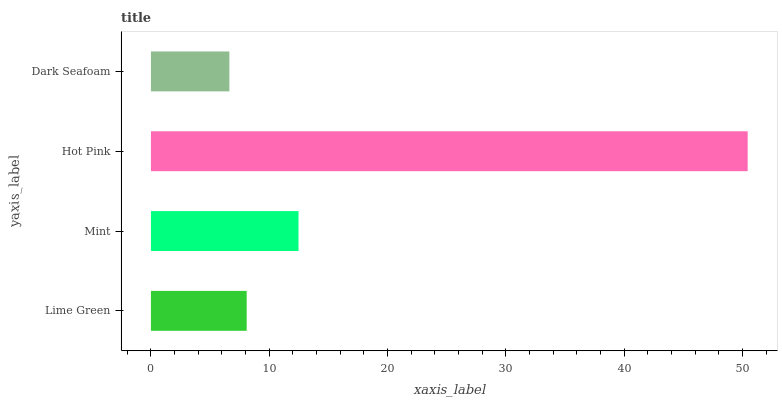Is Dark Seafoam the minimum?
Answer yes or no. Yes. Is Hot Pink the maximum?
Answer yes or no. Yes. Is Mint the minimum?
Answer yes or no. No. Is Mint the maximum?
Answer yes or no. No. Is Mint greater than Lime Green?
Answer yes or no. Yes. Is Lime Green less than Mint?
Answer yes or no. Yes. Is Lime Green greater than Mint?
Answer yes or no. No. Is Mint less than Lime Green?
Answer yes or no. No. Is Mint the high median?
Answer yes or no. Yes. Is Lime Green the low median?
Answer yes or no. Yes. Is Lime Green the high median?
Answer yes or no. No. Is Mint the low median?
Answer yes or no. No. 